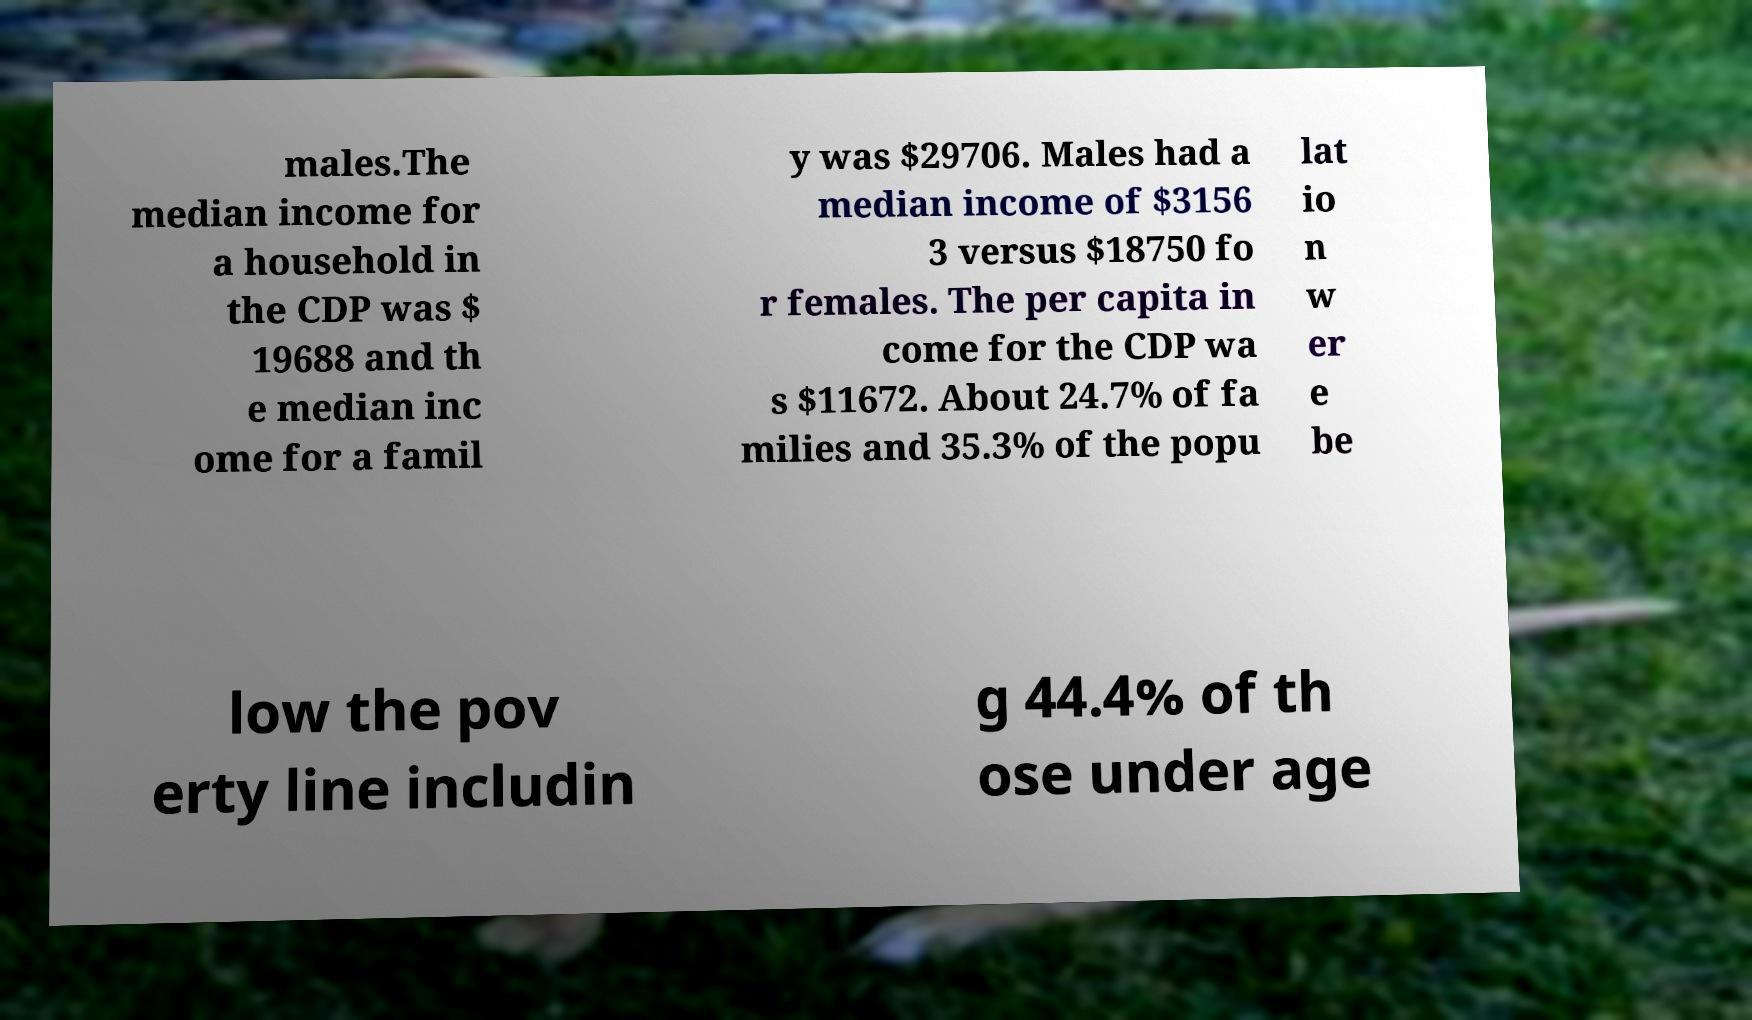For documentation purposes, I need the text within this image transcribed. Could you provide that? males.The median income for a household in the CDP was $ 19688 and th e median inc ome for a famil y was $29706. Males had a median income of $3156 3 versus $18750 fo r females. The per capita in come for the CDP wa s $11672. About 24.7% of fa milies and 35.3% of the popu lat io n w er e be low the pov erty line includin g 44.4% of th ose under age 